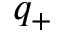<formula> <loc_0><loc_0><loc_500><loc_500>q _ { + }</formula> 